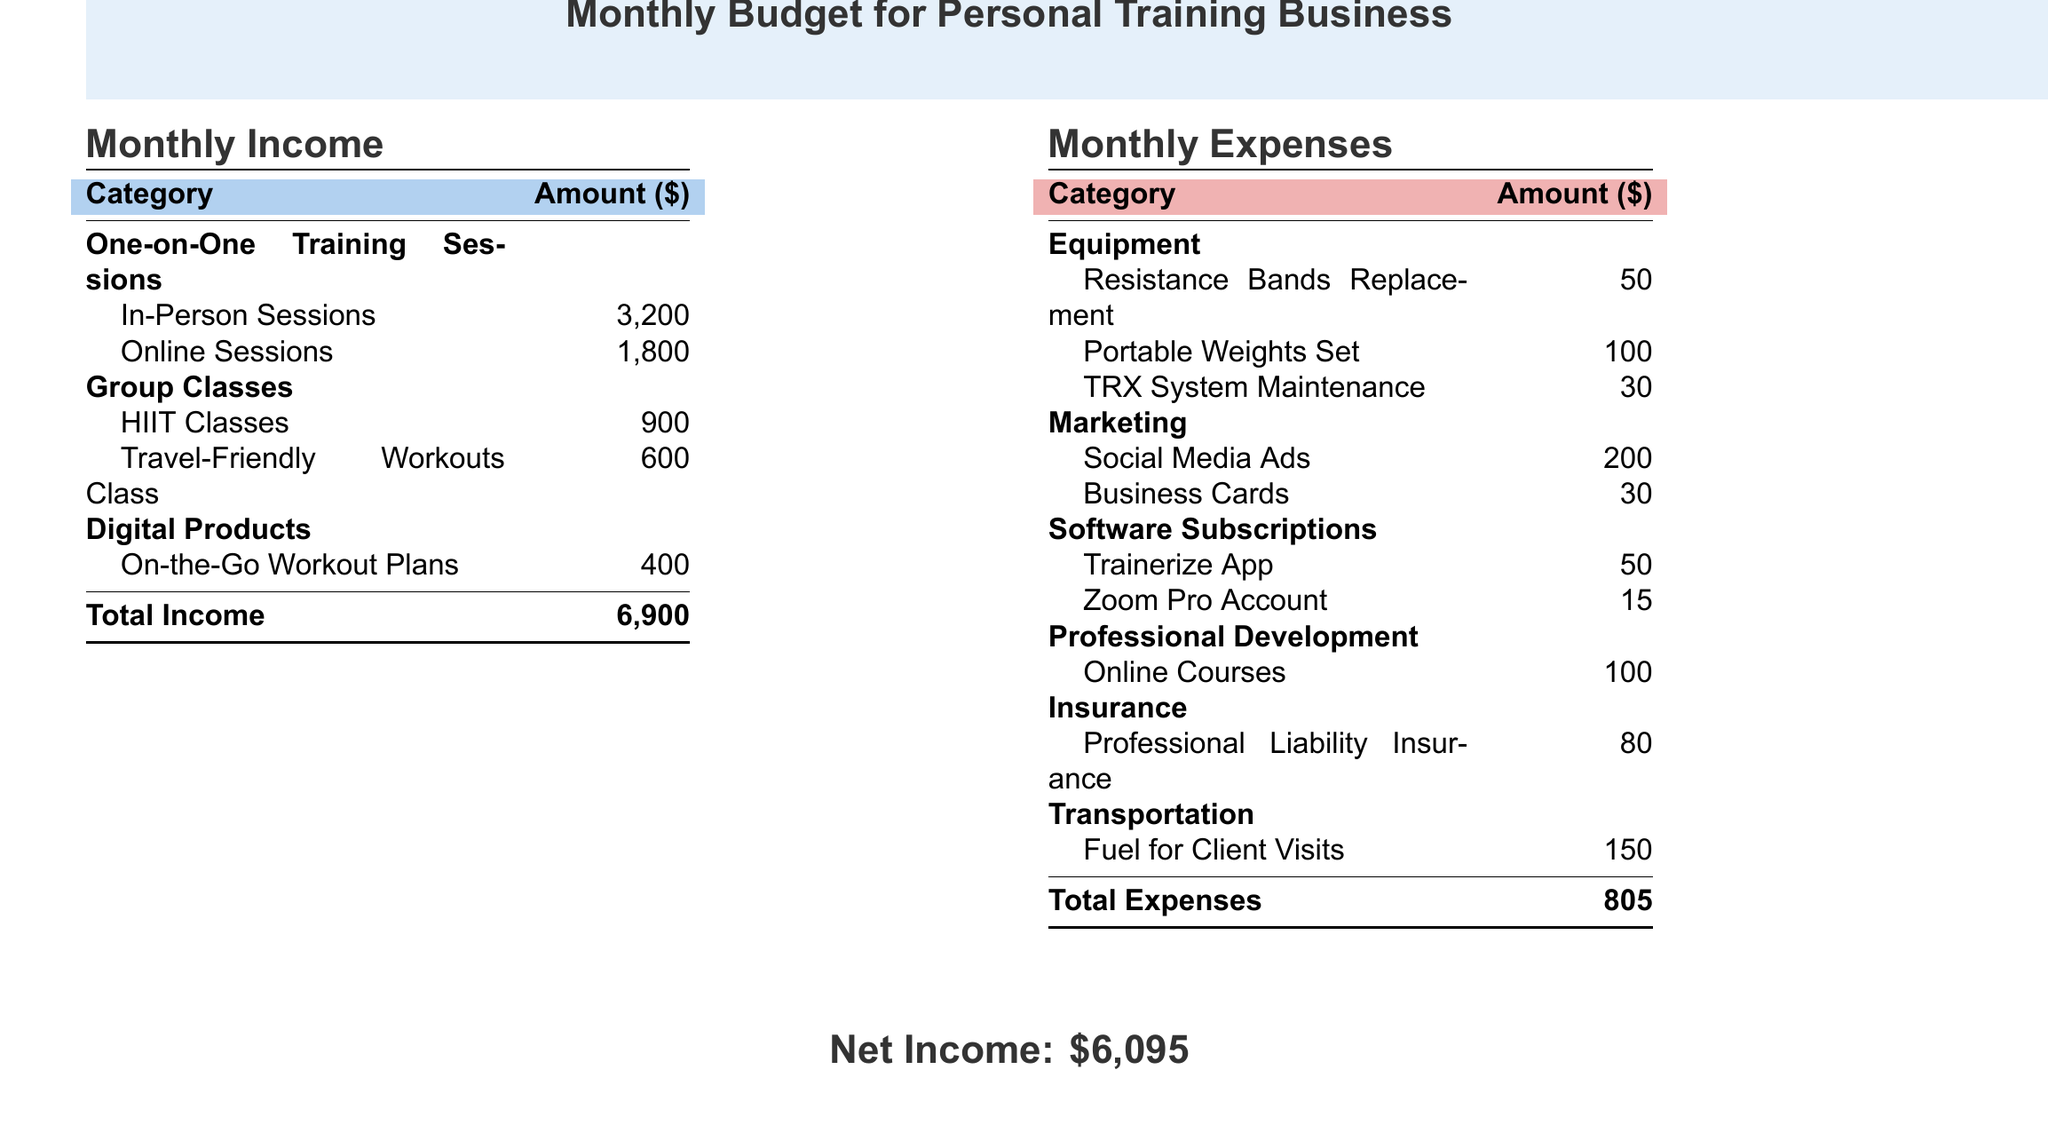What is the total income? The total income is stated at the bottom of the income section in the document, which is the sum of all income categories.
Answer: 6,900 How much is earned from one-on-one training sessions? This amount can be found in the income section of the document, specifically listed under one-on-one training sessions.
Answer: 5,000 What is the expense for portable weights set? This expense is detailed under the equipment category in the expenses section of the document.
Answer: 100 What is the cost of professional liability insurance? This cost is located under the insurance category in the expenses section of the document.
Answer: 80 What is the net income? The net income is calculated by subtracting total expenses from total income, which is stated at the end of the document.
Answer: 6,095 How much is spent on marketing? This total can be found by adding up all the marketing expenses, which are listed in the expenses section.
Answer: 230 What type of insurance is mentioned in the document? The insurance category lists a specific type of insurance that is relevant to the business in the document.
Answer: Professional Liability Insurance How much is spent on software subscriptions? This total is detailed in the expenses section, specifically under the software subscriptions category.
Answer: 65 